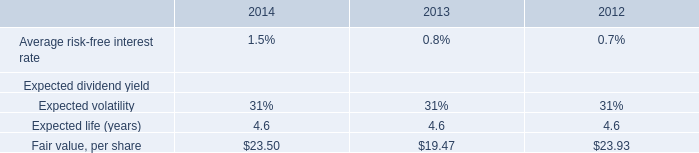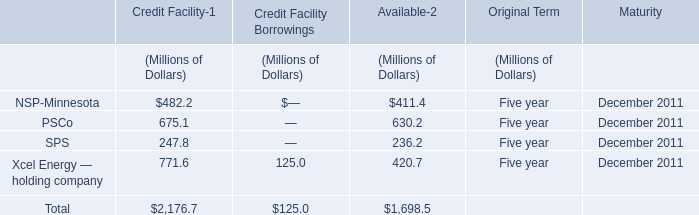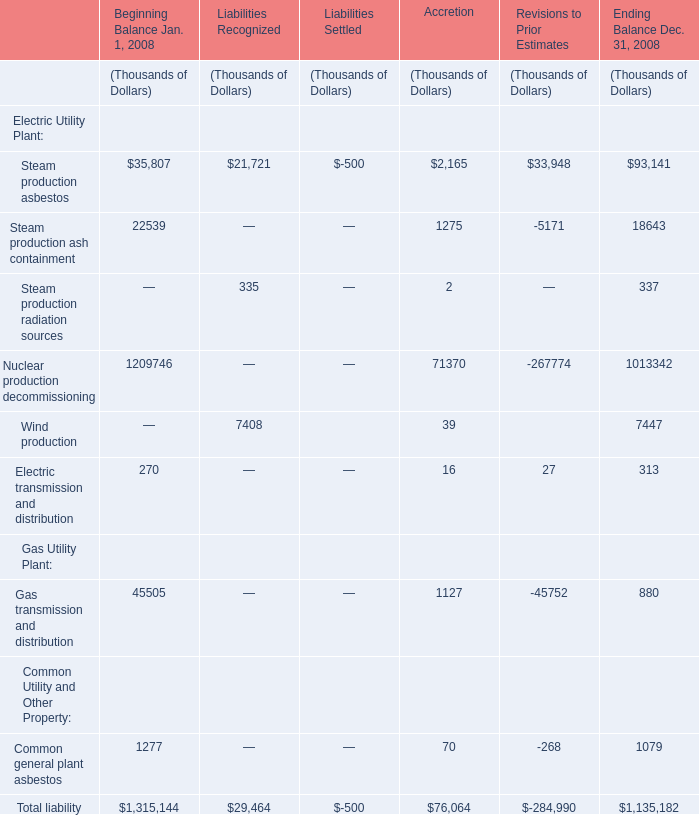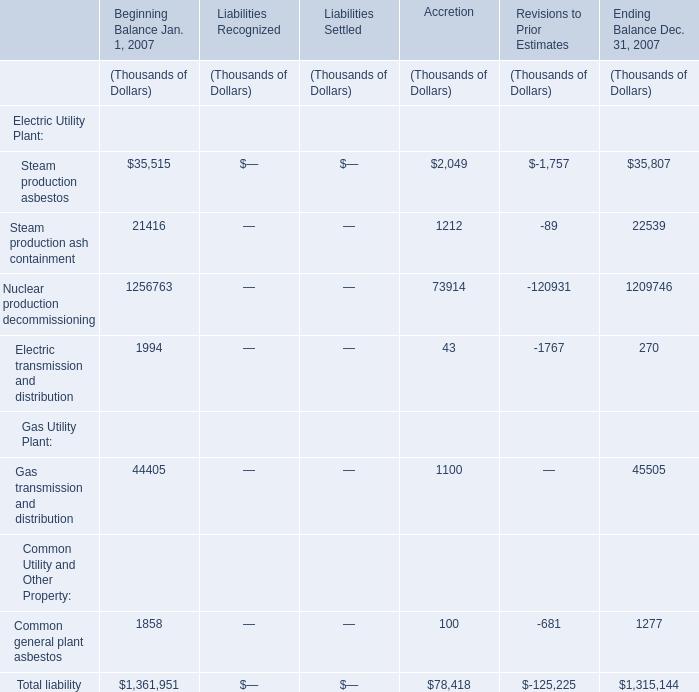What is the sum of the Total liability of Gas Utility Plant in the sections where Steam production asbestos is positive for Electric Utility Plant? (in Thousand) 
Computations: ((((1315144 + 29464) + 76064) - 284990) + 1135182)
Answer: 2270864.0. 